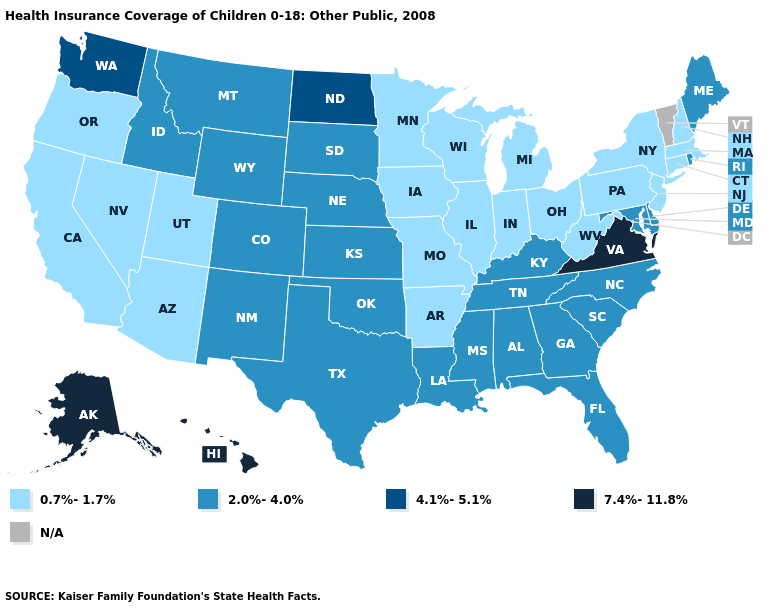What is the lowest value in states that border Georgia?
Concise answer only. 2.0%-4.0%. Which states have the lowest value in the USA?
Quick response, please. Arizona, Arkansas, California, Connecticut, Illinois, Indiana, Iowa, Massachusetts, Michigan, Minnesota, Missouri, Nevada, New Hampshire, New Jersey, New York, Ohio, Oregon, Pennsylvania, Utah, West Virginia, Wisconsin. Does the first symbol in the legend represent the smallest category?
Give a very brief answer. Yes. What is the value of Georgia?
Be succinct. 2.0%-4.0%. Does the map have missing data?
Keep it brief. Yes. Name the states that have a value in the range 4.1%-5.1%?
Concise answer only. North Dakota, Washington. Name the states that have a value in the range N/A?
Be succinct. Vermont. What is the highest value in the West ?
Answer briefly. 7.4%-11.8%. What is the value of Maine?
Give a very brief answer. 2.0%-4.0%. What is the highest value in the South ?
Quick response, please. 7.4%-11.8%. How many symbols are there in the legend?
Answer briefly. 5. What is the value of South Carolina?
Keep it brief. 2.0%-4.0%. What is the highest value in states that border Maryland?
Give a very brief answer. 7.4%-11.8%. 